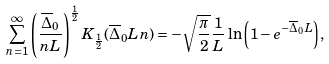<formula> <loc_0><loc_0><loc_500><loc_500>\sum _ { n = 1 } ^ { \infty } \left ( \frac { \overline { \Delta } _ { 0 } } { n L } \right ) ^ { \frac { 1 } { 2 } } K _ { \frac { 1 } { 2 } } ( \overline { \Delta } _ { 0 } L n ) = - \sqrt { \frac { \pi } { 2 } } \frac { 1 } { L } \ln { \left ( 1 - e ^ { - \overline { \Delta } _ { 0 } L } \right ) } ,</formula> 